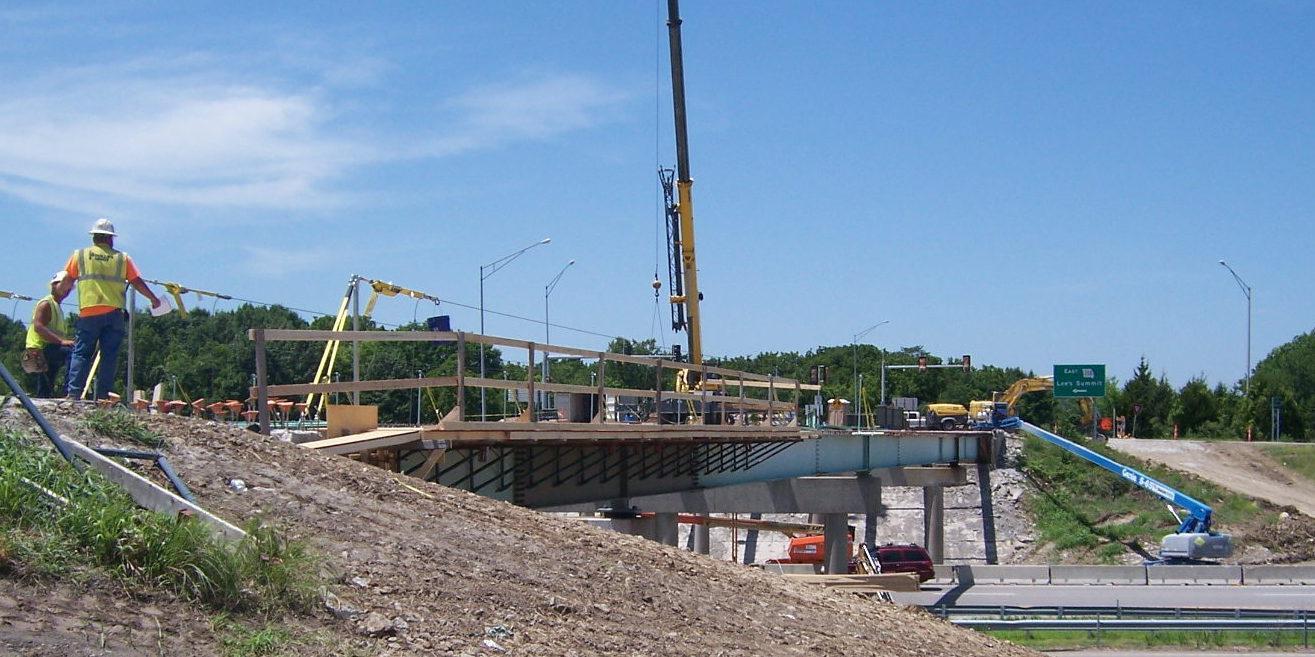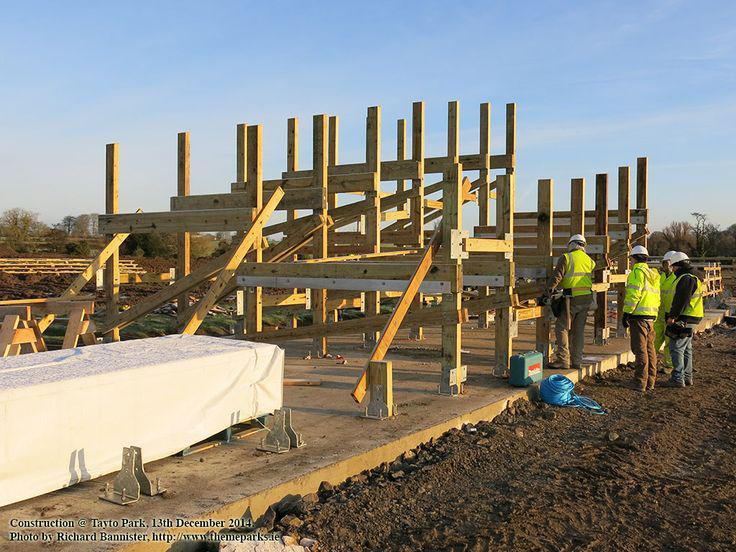The first image is the image on the left, the second image is the image on the right. Analyze the images presented: Is the assertion "In one image there are at least two cranes." valid? Answer yes or no. Yes. 